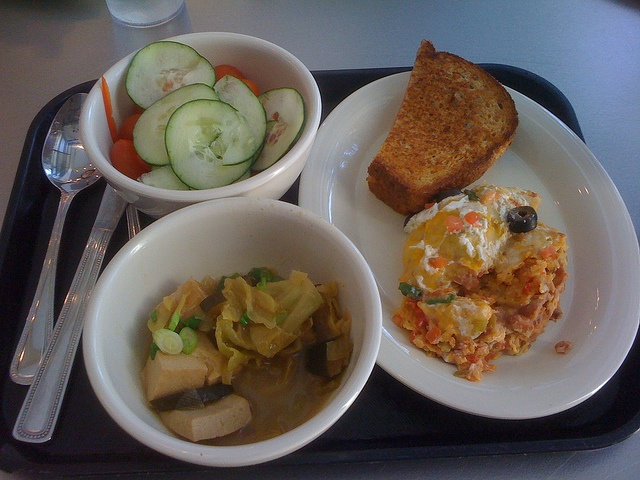Describe the objects in this image and their specific colors. I can see bowl in black, darkgray, maroon, brown, and gray tones, bowl in black, darkgray, olive, maroon, and gray tones, bowl in black, darkgray, gray, and maroon tones, sandwich in black, maroon, brown, and gray tones, and spoon in black and gray tones in this image. 